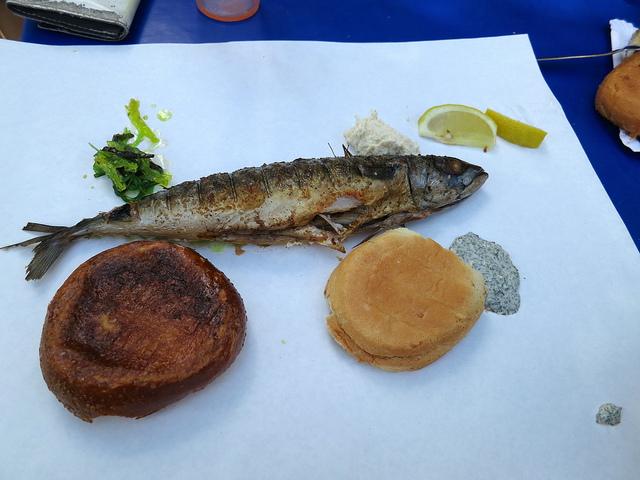Is there fish in the image?
Short answer required. Yes. What is under the food?
Keep it brief. Paper. How many lemon slices are in this photo?
Keep it brief. 2. 